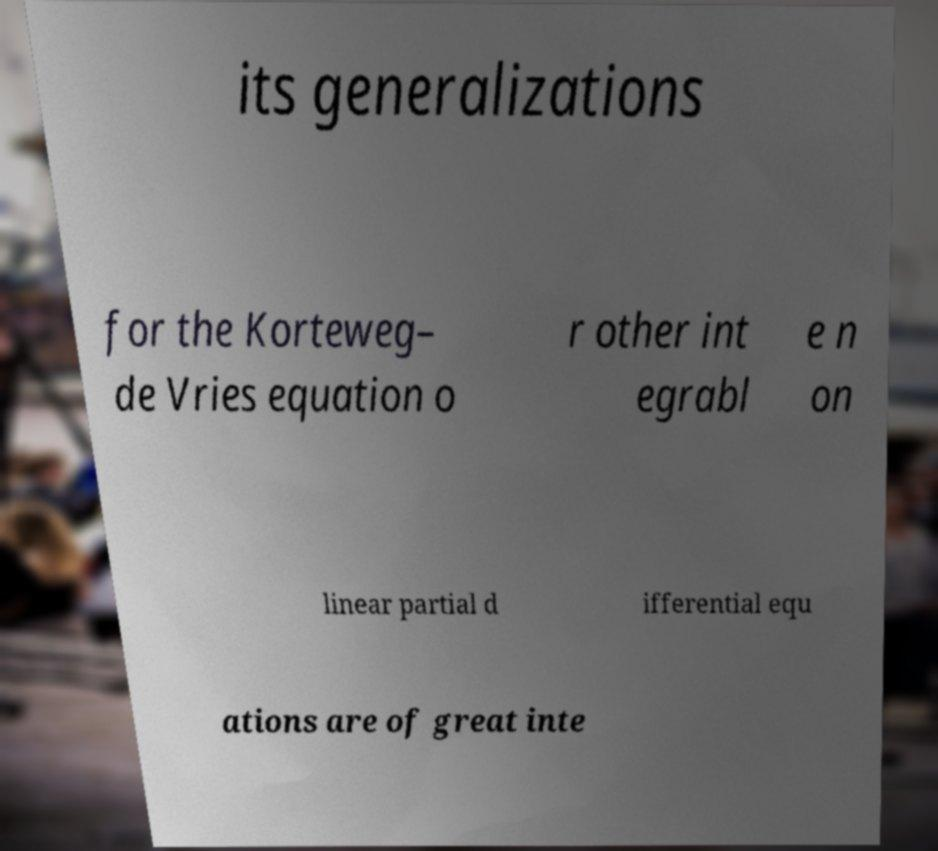I need the written content from this picture converted into text. Can you do that? its generalizations for the Korteweg– de Vries equation o r other int egrabl e n on linear partial d ifferential equ ations are of great inte 